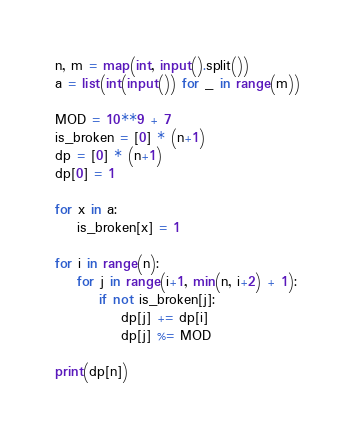<code> <loc_0><loc_0><loc_500><loc_500><_Python_>n, m = map(int, input().split())
a = list(int(input()) for _ in range(m))

MOD = 10**9 + 7
is_broken = [0] * (n+1)
dp = [0] * (n+1)
dp[0] = 1

for x in a:
    is_broken[x] = 1

for i in range(n):
    for j in range(i+1, min(n, i+2) + 1):
        if not is_broken[j]:
            dp[j] += dp[i]
            dp[j] %= MOD

print(dp[n])
</code> 